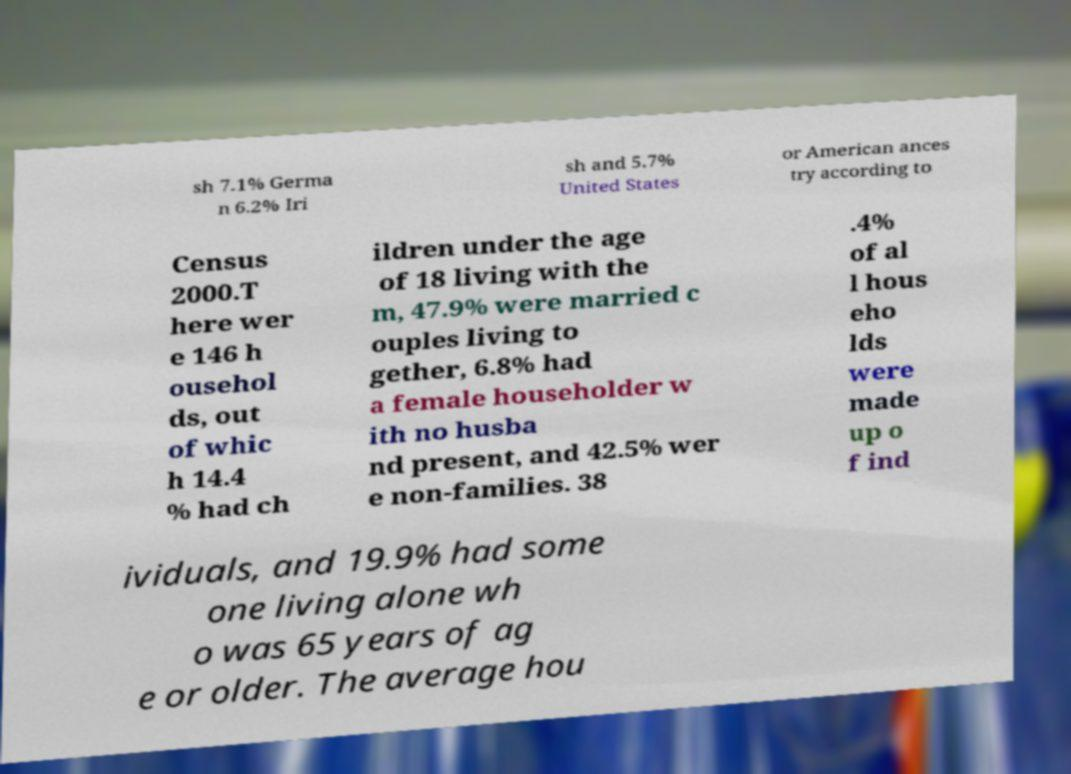Can you read and provide the text displayed in the image?This photo seems to have some interesting text. Can you extract and type it out for me? sh 7.1% Germa n 6.2% Iri sh and 5.7% United States or American ances try according to Census 2000.T here wer e 146 h ousehol ds, out of whic h 14.4 % had ch ildren under the age of 18 living with the m, 47.9% were married c ouples living to gether, 6.8% had a female householder w ith no husba nd present, and 42.5% wer e non-families. 38 .4% of al l hous eho lds were made up o f ind ividuals, and 19.9% had some one living alone wh o was 65 years of ag e or older. The average hou 